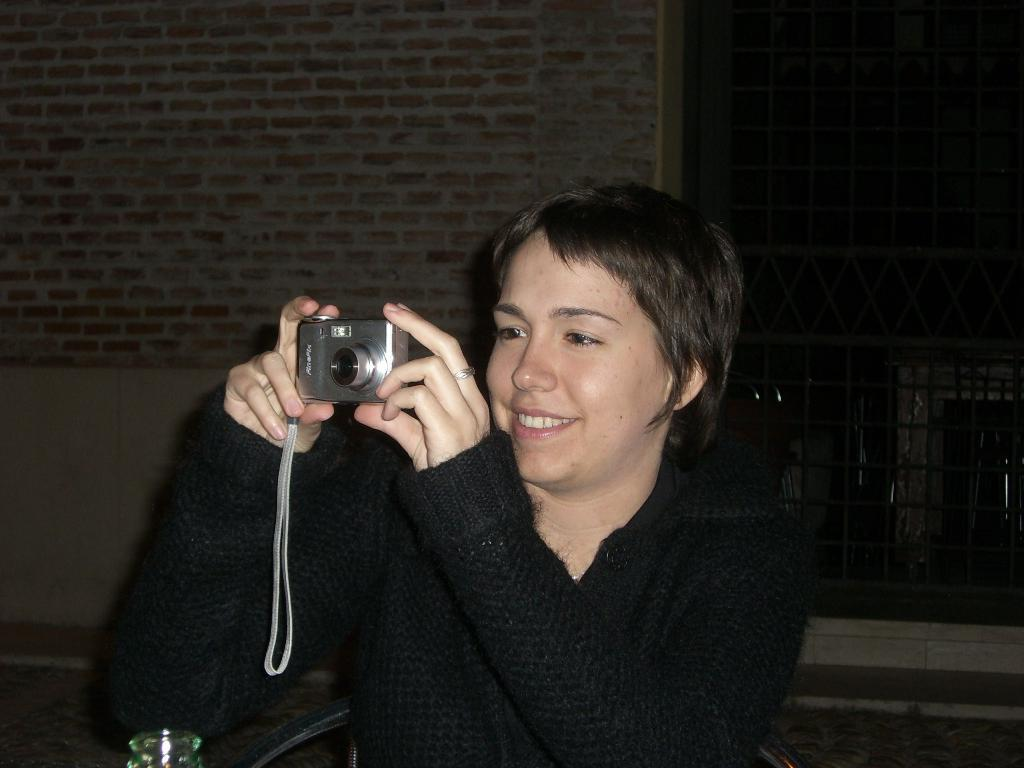What is the woman doing in the image? The woman is seated in the image. What is the woman's facial expression? The woman is smiling in the image. What object is the woman holding in her hand? The woman is holding a camera in her hand. What type of tooth can be seen in the woman's mouth in the image? There is no tooth visible in the woman's mouth in the image. What is the texture of the woman's clothing in the image? The provided facts do not mention the texture of the woman's clothing, so it cannot be determined from the image. 